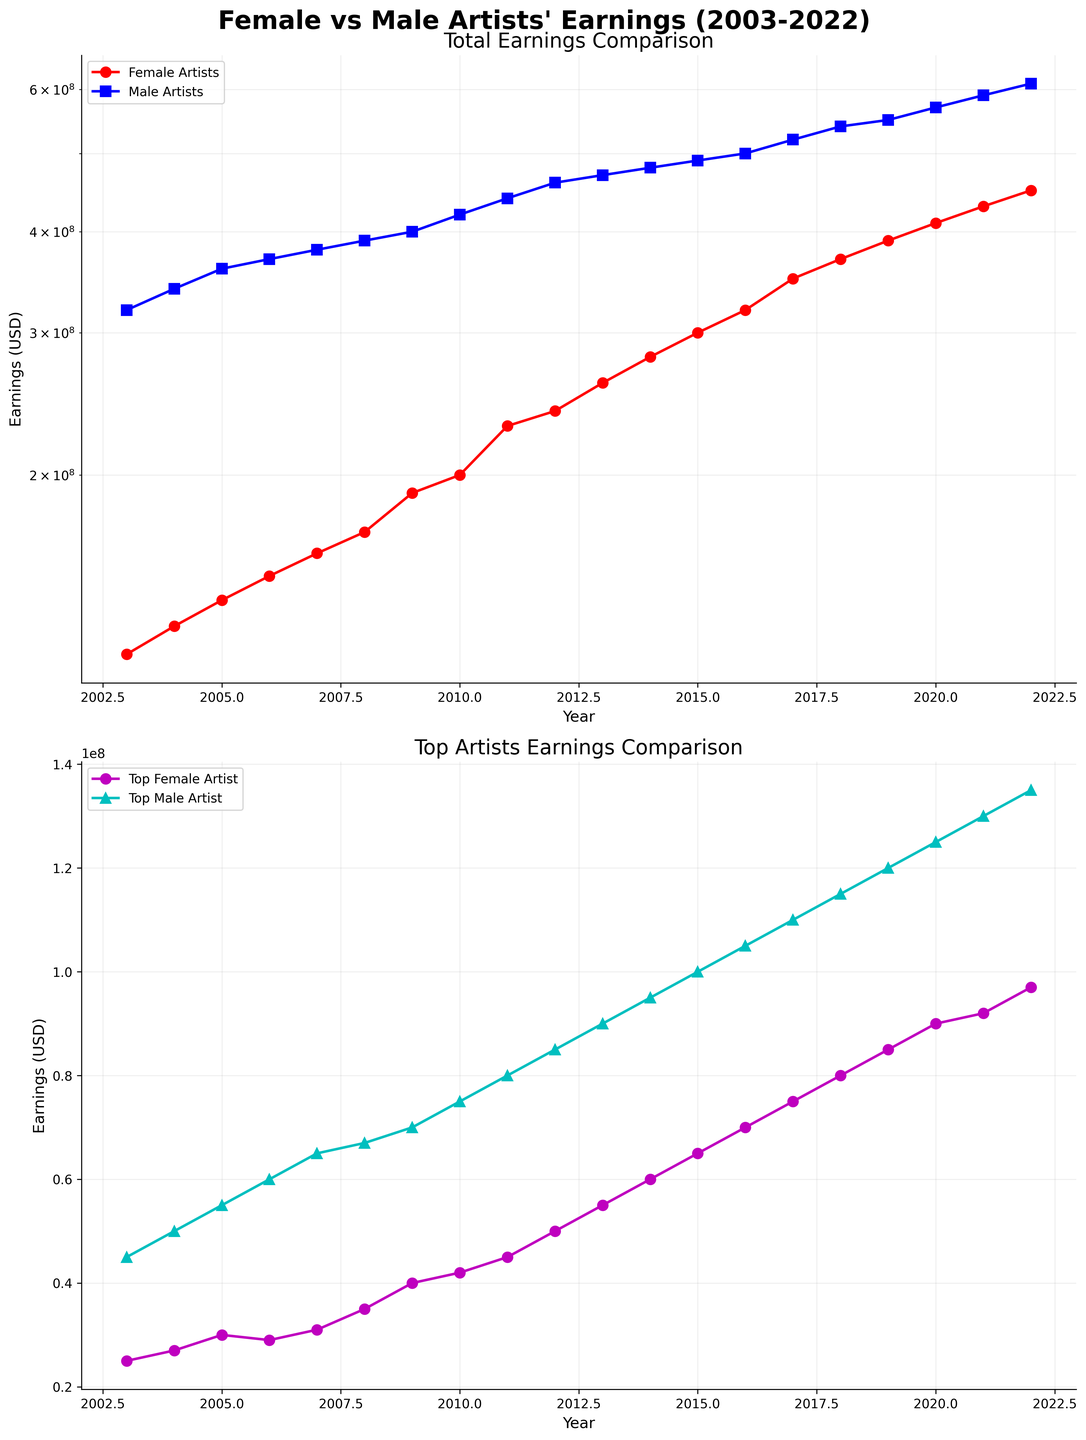What is the title of the figure? The title is at the top of the figure in bold and large font. It reads "Female vs Male Artists' Earnings (2003-2022)".
Answer: Female vs Male Artists' Earnings (2003-2022) How do the earnings of female artists in 2003 compare to their earnings in 2022? In 2003, the earnings of female artists were indicated by a red line on the semilogarithmic scale, approximately at $120,000,000. By 2022, the red line for female artists’ earnings rose close to $450,000,000, showing a significant increase.
Answer: Increased What trend can be observed about the earnings of male artists over the given period? The blue line on the semilogarithmic plot for male artists’ earnings shows an upward trajectory from approximately $320,000,000 in 2003 to around $610,000,000 in 2022, indicating consistent growth.
Answer: Consistent growth Who was the top-earning female artist in 2009, and how much did she earn? The second subplot (Top Artists Earnings Comparison) shows data points in magenta marking top female artists' earnings using a circle marker. By looking closely at 2009, Lady Gaga is listed as the top female artist, and her earnings were around $40,000,000.
Answer: Lady Gaga, $40,000,000 Which year had the smallest earnings gap between the top female artist and top male artist, and what was the gap? By comparing earnings on the second subplot (with lines representing top female and male artists' earnings), the smallest gap appears in 2007. In that year, Rihanna earned about $31,000,000 while Justin Timberlake earned about $65,000,000, giving a gap of around $34,000,000.
Answer: 2007, $34,000,000 How many times do the earnings of female artists surpass $300,000,000? On the semilogarithmic plot (Top Earnings Comparison), the red line marking female artists' earnings crosses the $300,000,000 line in three years: 2015, 2016, and each subsequent year until 2022.
Answer: 7 times In which year did the earnings of the top female artist first exceed $50,000,000? Referring to the second subplot, the magenta circles marking top female artist earnings exceed $50,000,000 in 2012 with Adele earning exactly that amount.
Answer: 2012 In 2015, by how much more did the top male artist earn compared to the top female artist? The second subplot shows in 2015, Rihanna earned $65,000,000, and Drake earned $100,000,000. The difference is $100,000,000 - $65,000,000 = $35,000,000.
Answer: $35,000,000 How does the growth trend of total earnings for female artists compare with the growth trend of male artists? Both trends in the first subplot (Total Earnings Comparison) show an upward trajectory. However, male artist earnings (blue line) start higher and continuously grow, while female artist earnings (red line) also show consistent growth starting from a lower base and seeing significant rises, especially after 2010.
Answer: Both show growth, male starts higher 